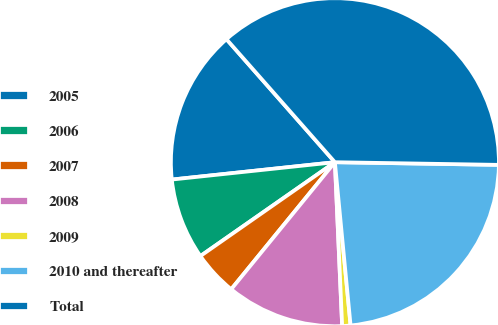Convert chart. <chart><loc_0><loc_0><loc_500><loc_500><pie_chart><fcel>2005<fcel>2006<fcel>2007<fcel>2008<fcel>2009<fcel>2010 and thereafter<fcel>Total<nl><fcel>15.19%<fcel>8.01%<fcel>4.41%<fcel>11.6%<fcel>0.82%<fcel>23.22%<fcel>36.76%<nl></chart> 